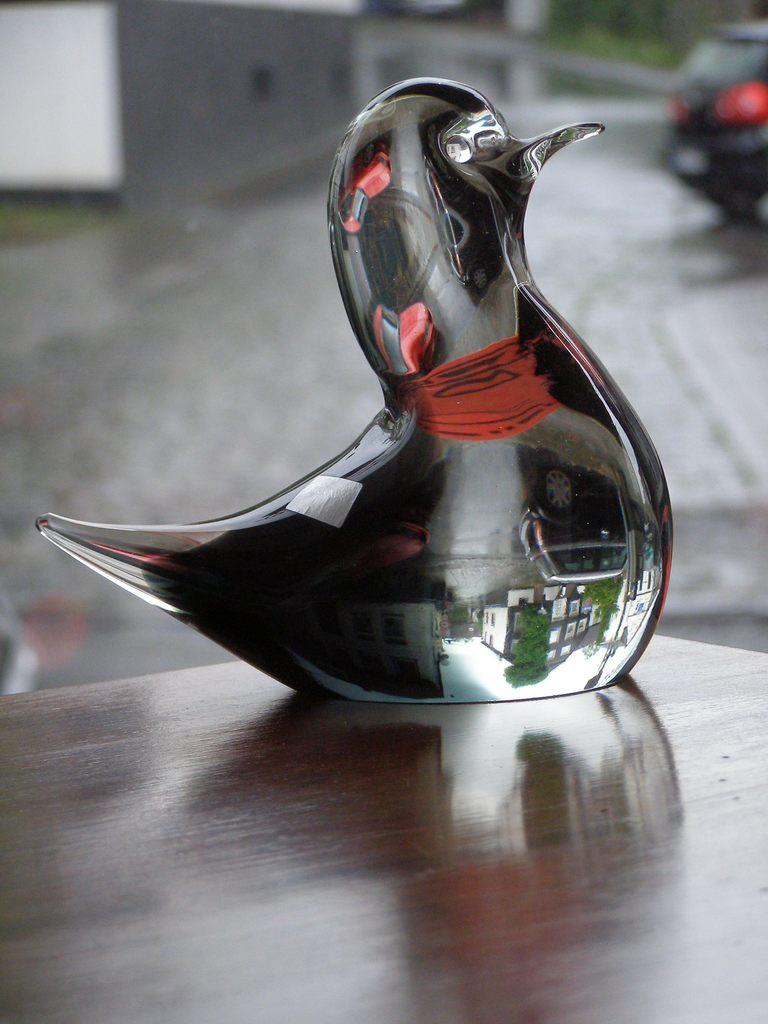What type of structure is present in the image? There is a bird structure in the image. What material is the bird structure made of? The bird structure is made from glass. What type of pie is being served to the judge in the image? There is no pie or judge present in the image; it only features a bird structure made of glass. 